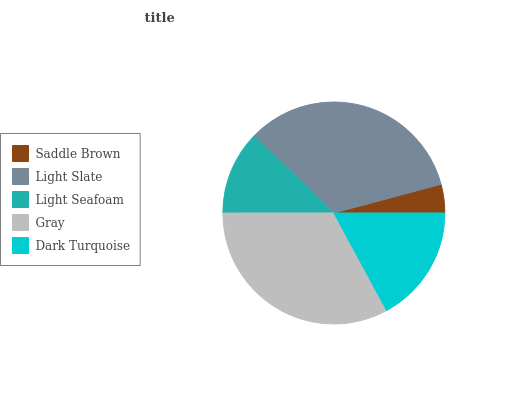Is Saddle Brown the minimum?
Answer yes or no. Yes. Is Light Slate the maximum?
Answer yes or no. Yes. Is Light Seafoam the minimum?
Answer yes or no. No. Is Light Seafoam the maximum?
Answer yes or no. No. Is Light Slate greater than Light Seafoam?
Answer yes or no. Yes. Is Light Seafoam less than Light Slate?
Answer yes or no. Yes. Is Light Seafoam greater than Light Slate?
Answer yes or no. No. Is Light Slate less than Light Seafoam?
Answer yes or no. No. Is Dark Turquoise the high median?
Answer yes or no. Yes. Is Dark Turquoise the low median?
Answer yes or no. Yes. Is Light Seafoam the high median?
Answer yes or no. No. Is Light Slate the low median?
Answer yes or no. No. 